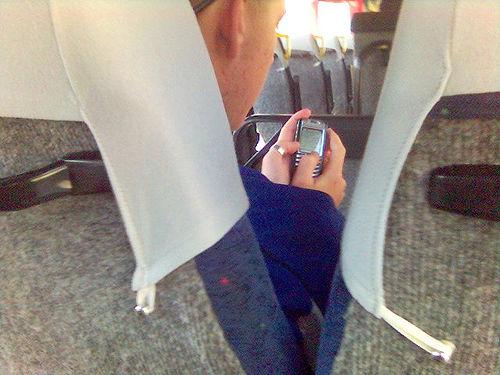What is this person texting?
Give a very brief answer. Message. Would this be a male or female?
Keep it brief. Male. What is this person thinking?
Write a very short answer. Yes. 